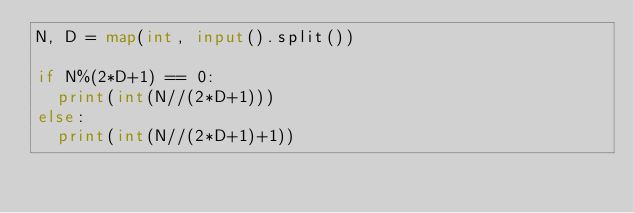Convert code to text. <code><loc_0><loc_0><loc_500><loc_500><_Python_>N, D = map(int, input().split())

if N%(2*D+1) == 0:
  print(int(N//(2*D+1)))
else:
  print(int(N//(2*D+1)+1))</code> 